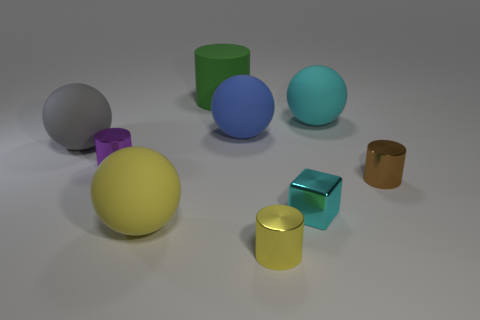Are there fewer tiny brown shiny cylinders than cyan metallic cylinders?
Offer a terse response. No. Is the color of the matte cylinder the same as the cylinder to the left of the large green cylinder?
Provide a short and direct response. No. Are there an equal number of large cyan objects that are behind the large gray matte object and things that are behind the tiny purple object?
Give a very brief answer. No. How many other big rubber objects are the same shape as the large cyan object?
Offer a very short reply. 3. Is there a tiny brown matte thing?
Your answer should be compact. No. Does the brown object have the same material as the cyan object that is in front of the small purple metallic cylinder?
Make the answer very short. Yes. There is a purple object that is the same size as the cyan shiny cube; what is its material?
Provide a short and direct response. Metal. Is there a big yellow object made of the same material as the tiny purple thing?
Provide a short and direct response. No. There is a block to the right of the cylinder to the left of the yellow ball; are there any matte cylinders that are in front of it?
Your answer should be compact. No. What shape is the cyan shiny object that is the same size as the brown shiny thing?
Offer a terse response. Cube. 